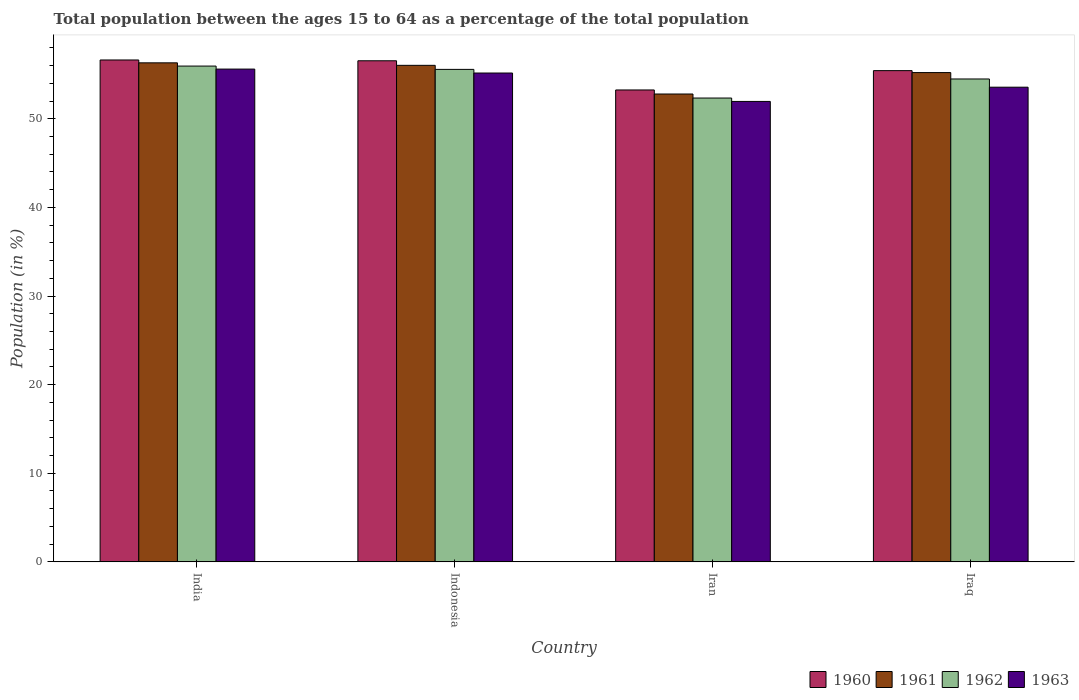How many different coloured bars are there?
Provide a succinct answer. 4. How many groups of bars are there?
Provide a succinct answer. 4. Are the number of bars per tick equal to the number of legend labels?
Provide a short and direct response. Yes. Are the number of bars on each tick of the X-axis equal?
Offer a very short reply. Yes. What is the label of the 2nd group of bars from the left?
Your response must be concise. Indonesia. What is the percentage of the population ages 15 to 64 in 1963 in Indonesia?
Provide a short and direct response. 55.17. Across all countries, what is the maximum percentage of the population ages 15 to 64 in 1961?
Provide a succinct answer. 56.32. Across all countries, what is the minimum percentage of the population ages 15 to 64 in 1960?
Offer a terse response. 53.25. In which country was the percentage of the population ages 15 to 64 in 1960 minimum?
Give a very brief answer. Iran. What is the total percentage of the population ages 15 to 64 in 1961 in the graph?
Keep it short and to the point. 220.36. What is the difference between the percentage of the population ages 15 to 64 in 1962 in India and that in Iran?
Offer a terse response. 3.61. What is the difference between the percentage of the population ages 15 to 64 in 1961 in Iran and the percentage of the population ages 15 to 64 in 1962 in India?
Give a very brief answer. -3.15. What is the average percentage of the population ages 15 to 64 in 1963 per country?
Provide a short and direct response. 54.08. What is the difference between the percentage of the population ages 15 to 64 of/in 1961 and percentage of the population ages 15 to 64 of/in 1960 in Iran?
Offer a terse response. -0.46. In how many countries, is the percentage of the population ages 15 to 64 in 1961 greater than 52?
Make the answer very short. 4. What is the ratio of the percentage of the population ages 15 to 64 in 1962 in India to that in Iraq?
Make the answer very short. 1.03. Is the percentage of the population ages 15 to 64 in 1961 in Indonesia less than that in Iraq?
Keep it short and to the point. No. Is the difference between the percentage of the population ages 15 to 64 in 1961 in Indonesia and Iraq greater than the difference between the percentage of the population ages 15 to 64 in 1960 in Indonesia and Iraq?
Provide a succinct answer. No. What is the difference between the highest and the second highest percentage of the population ages 15 to 64 in 1961?
Ensure brevity in your answer.  0.28. What is the difference between the highest and the lowest percentage of the population ages 15 to 64 in 1962?
Provide a succinct answer. 3.61. In how many countries, is the percentage of the population ages 15 to 64 in 1962 greater than the average percentage of the population ages 15 to 64 in 1962 taken over all countries?
Offer a terse response. 2. Is it the case that in every country, the sum of the percentage of the population ages 15 to 64 in 1963 and percentage of the population ages 15 to 64 in 1962 is greater than the sum of percentage of the population ages 15 to 64 in 1960 and percentage of the population ages 15 to 64 in 1961?
Give a very brief answer. No. What does the 1st bar from the left in Indonesia represents?
Give a very brief answer. 1960. Is it the case that in every country, the sum of the percentage of the population ages 15 to 64 in 1963 and percentage of the population ages 15 to 64 in 1961 is greater than the percentage of the population ages 15 to 64 in 1962?
Provide a short and direct response. Yes. How many bars are there?
Ensure brevity in your answer.  16. How many countries are there in the graph?
Your answer should be compact. 4. Does the graph contain any zero values?
Provide a short and direct response. No. What is the title of the graph?
Ensure brevity in your answer.  Total population between the ages 15 to 64 as a percentage of the total population. What is the label or title of the X-axis?
Your response must be concise. Country. What is the Population (in %) of 1960 in India?
Your answer should be very brief. 56.64. What is the Population (in %) of 1961 in India?
Offer a terse response. 56.32. What is the Population (in %) of 1962 in India?
Offer a terse response. 55.95. What is the Population (in %) of 1963 in India?
Your response must be concise. 55.61. What is the Population (in %) in 1960 in Indonesia?
Ensure brevity in your answer.  56.55. What is the Population (in %) in 1961 in Indonesia?
Make the answer very short. 56.03. What is the Population (in %) of 1962 in Indonesia?
Ensure brevity in your answer.  55.58. What is the Population (in %) of 1963 in Indonesia?
Provide a short and direct response. 55.17. What is the Population (in %) in 1960 in Iran?
Keep it short and to the point. 53.25. What is the Population (in %) of 1961 in Iran?
Make the answer very short. 52.8. What is the Population (in %) of 1962 in Iran?
Keep it short and to the point. 52.34. What is the Population (in %) of 1963 in Iran?
Keep it short and to the point. 51.96. What is the Population (in %) in 1960 in Iraq?
Keep it short and to the point. 55.43. What is the Population (in %) of 1961 in Iraq?
Offer a very short reply. 55.22. What is the Population (in %) of 1962 in Iraq?
Your answer should be compact. 54.49. What is the Population (in %) in 1963 in Iraq?
Keep it short and to the point. 53.57. Across all countries, what is the maximum Population (in %) in 1960?
Give a very brief answer. 56.64. Across all countries, what is the maximum Population (in %) of 1961?
Keep it short and to the point. 56.32. Across all countries, what is the maximum Population (in %) of 1962?
Ensure brevity in your answer.  55.95. Across all countries, what is the maximum Population (in %) of 1963?
Ensure brevity in your answer.  55.61. Across all countries, what is the minimum Population (in %) in 1960?
Provide a succinct answer. 53.25. Across all countries, what is the minimum Population (in %) of 1961?
Offer a very short reply. 52.8. Across all countries, what is the minimum Population (in %) of 1962?
Your response must be concise. 52.34. Across all countries, what is the minimum Population (in %) of 1963?
Give a very brief answer. 51.96. What is the total Population (in %) of 1960 in the graph?
Keep it short and to the point. 221.87. What is the total Population (in %) in 1961 in the graph?
Make the answer very short. 220.36. What is the total Population (in %) of 1962 in the graph?
Your response must be concise. 218.36. What is the total Population (in %) of 1963 in the graph?
Give a very brief answer. 216.3. What is the difference between the Population (in %) of 1960 in India and that in Indonesia?
Make the answer very short. 0.09. What is the difference between the Population (in %) in 1961 in India and that in Indonesia?
Provide a succinct answer. 0.28. What is the difference between the Population (in %) of 1962 in India and that in Indonesia?
Keep it short and to the point. 0.37. What is the difference between the Population (in %) in 1963 in India and that in Indonesia?
Provide a succinct answer. 0.44. What is the difference between the Population (in %) of 1960 in India and that in Iran?
Provide a short and direct response. 3.38. What is the difference between the Population (in %) in 1961 in India and that in Iran?
Provide a succinct answer. 3.52. What is the difference between the Population (in %) of 1962 in India and that in Iran?
Make the answer very short. 3.61. What is the difference between the Population (in %) of 1963 in India and that in Iran?
Make the answer very short. 3.65. What is the difference between the Population (in %) in 1960 in India and that in Iraq?
Provide a short and direct response. 1.2. What is the difference between the Population (in %) in 1961 in India and that in Iraq?
Give a very brief answer. 1.1. What is the difference between the Population (in %) in 1962 in India and that in Iraq?
Your response must be concise. 1.46. What is the difference between the Population (in %) of 1963 in India and that in Iraq?
Offer a very short reply. 2.04. What is the difference between the Population (in %) in 1960 in Indonesia and that in Iran?
Keep it short and to the point. 3.29. What is the difference between the Population (in %) in 1961 in Indonesia and that in Iran?
Provide a short and direct response. 3.24. What is the difference between the Population (in %) of 1962 in Indonesia and that in Iran?
Your response must be concise. 3.23. What is the difference between the Population (in %) of 1963 in Indonesia and that in Iran?
Your response must be concise. 3.21. What is the difference between the Population (in %) of 1960 in Indonesia and that in Iraq?
Keep it short and to the point. 1.11. What is the difference between the Population (in %) of 1961 in Indonesia and that in Iraq?
Your response must be concise. 0.82. What is the difference between the Population (in %) in 1962 in Indonesia and that in Iraq?
Provide a short and direct response. 1.08. What is the difference between the Population (in %) of 1963 in Indonesia and that in Iraq?
Provide a short and direct response. 1.6. What is the difference between the Population (in %) of 1960 in Iran and that in Iraq?
Provide a succinct answer. -2.18. What is the difference between the Population (in %) in 1961 in Iran and that in Iraq?
Make the answer very short. -2.42. What is the difference between the Population (in %) of 1962 in Iran and that in Iraq?
Your answer should be compact. -2.15. What is the difference between the Population (in %) of 1963 in Iran and that in Iraq?
Make the answer very short. -1.61. What is the difference between the Population (in %) in 1960 in India and the Population (in %) in 1961 in Indonesia?
Your response must be concise. 0.6. What is the difference between the Population (in %) of 1960 in India and the Population (in %) of 1962 in Indonesia?
Provide a short and direct response. 1.06. What is the difference between the Population (in %) in 1960 in India and the Population (in %) in 1963 in Indonesia?
Make the answer very short. 1.47. What is the difference between the Population (in %) of 1961 in India and the Population (in %) of 1962 in Indonesia?
Your answer should be compact. 0.74. What is the difference between the Population (in %) in 1961 in India and the Population (in %) in 1963 in Indonesia?
Your answer should be compact. 1.15. What is the difference between the Population (in %) in 1962 in India and the Population (in %) in 1963 in Indonesia?
Give a very brief answer. 0.78. What is the difference between the Population (in %) in 1960 in India and the Population (in %) in 1961 in Iran?
Provide a succinct answer. 3.84. What is the difference between the Population (in %) of 1960 in India and the Population (in %) of 1962 in Iran?
Your response must be concise. 4.3. What is the difference between the Population (in %) of 1960 in India and the Population (in %) of 1963 in Iran?
Your response must be concise. 4.68. What is the difference between the Population (in %) of 1961 in India and the Population (in %) of 1962 in Iran?
Your response must be concise. 3.97. What is the difference between the Population (in %) in 1961 in India and the Population (in %) in 1963 in Iran?
Your answer should be compact. 4.36. What is the difference between the Population (in %) of 1962 in India and the Population (in %) of 1963 in Iran?
Give a very brief answer. 3.99. What is the difference between the Population (in %) in 1960 in India and the Population (in %) in 1961 in Iraq?
Provide a short and direct response. 1.42. What is the difference between the Population (in %) in 1960 in India and the Population (in %) in 1962 in Iraq?
Offer a terse response. 2.14. What is the difference between the Population (in %) of 1960 in India and the Population (in %) of 1963 in Iraq?
Give a very brief answer. 3.07. What is the difference between the Population (in %) in 1961 in India and the Population (in %) in 1962 in Iraq?
Your answer should be compact. 1.82. What is the difference between the Population (in %) of 1961 in India and the Population (in %) of 1963 in Iraq?
Give a very brief answer. 2.75. What is the difference between the Population (in %) of 1962 in India and the Population (in %) of 1963 in Iraq?
Make the answer very short. 2.38. What is the difference between the Population (in %) in 1960 in Indonesia and the Population (in %) in 1961 in Iran?
Provide a short and direct response. 3.75. What is the difference between the Population (in %) of 1960 in Indonesia and the Population (in %) of 1962 in Iran?
Your answer should be very brief. 4.2. What is the difference between the Population (in %) of 1960 in Indonesia and the Population (in %) of 1963 in Iran?
Offer a terse response. 4.59. What is the difference between the Population (in %) in 1961 in Indonesia and the Population (in %) in 1962 in Iran?
Make the answer very short. 3.69. What is the difference between the Population (in %) of 1961 in Indonesia and the Population (in %) of 1963 in Iran?
Your response must be concise. 4.07. What is the difference between the Population (in %) in 1962 in Indonesia and the Population (in %) in 1963 in Iran?
Your response must be concise. 3.62. What is the difference between the Population (in %) in 1960 in Indonesia and the Population (in %) in 1961 in Iraq?
Offer a terse response. 1.33. What is the difference between the Population (in %) in 1960 in Indonesia and the Population (in %) in 1962 in Iraq?
Your response must be concise. 2.05. What is the difference between the Population (in %) of 1960 in Indonesia and the Population (in %) of 1963 in Iraq?
Offer a terse response. 2.98. What is the difference between the Population (in %) of 1961 in Indonesia and the Population (in %) of 1962 in Iraq?
Offer a very short reply. 1.54. What is the difference between the Population (in %) of 1961 in Indonesia and the Population (in %) of 1963 in Iraq?
Your answer should be very brief. 2.47. What is the difference between the Population (in %) in 1962 in Indonesia and the Population (in %) in 1963 in Iraq?
Offer a terse response. 2.01. What is the difference between the Population (in %) of 1960 in Iran and the Population (in %) of 1961 in Iraq?
Provide a succinct answer. -1.96. What is the difference between the Population (in %) in 1960 in Iran and the Population (in %) in 1962 in Iraq?
Offer a terse response. -1.24. What is the difference between the Population (in %) in 1960 in Iran and the Population (in %) in 1963 in Iraq?
Ensure brevity in your answer.  -0.31. What is the difference between the Population (in %) in 1961 in Iran and the Population (in %) in 1962 in Iraq?
Your answer should be compact. -1.7. What is the difference between the Population (in %) of 1961 in Iran and the Population (in %) of 1963 in Iraq?
Your answer should be very brief. -0.77. What is the difference between the Population (in %) of 1962 in Iran and the Population (in %) of 1963 in Iraq?
Ensure brevity in your answer.  -1.22. What is the average Population (in %) of 1960 per country?
Give a very brief answer. 55.47. What is the average Population (in %) in 1961 per country?
Offer a very short reply. 55.09. What is the average Population (in %) in 1962 per country?
Your response must be concise. 54.59. What is the average Population (in %) in 1963 per country?
Give a very brief answer. 54.08. What is the difference between the Population (in %) in 1960 and Population (in %) in 1961 in India?
Provide a succinct answer. 0.32. What is the difference between the Population (in %) of 1960 and Population (in %) of 1962 in India?
Make the answer very short. 0.69. What is the difference between the Population (in %) of 1960 and Population (in %) of 1963 in India?
Make the answer very short. 1.03. What is the difference between the Population (in %) of 1961 and Population (in %) of 1962 in India?
Provide a succinct answer. 0.37. What is the difference between the Population (in %) of 1961 and Population (in %) of 1963 in India?
Your answer should be very brief. 0.71. What is the difference between the Population (in %) in 1962 and Population (in %) in 1963 in India?
Ensure brevity in your answer.  0.34. What is the difference between the Population (in %) of 1960 and Population (in %) of 1961 in Indonesia?
Your answer should be compact. 0.51. What is the difference between the Population (in %) in 1960 and Population (in %) in 1963 in Indonesia?
Make the answer very short. 1.38. What is the difference between the Population (in %) of 1961 and Population (in %) of 1962 in Indonesia?
Your answer should be compact. 0.46. What is the difference between the Population (in %) of 1961 and Population (in %) of 1963 in Indonesia?
Keep it short and to the point. 0.87. What is the difference between the Population (in %) in 1962 and Population (in %) in 1963 in Indonesia?
Provide a short and direct response. 0.41. What is the difference between the Population (in %) in 1960 and Population (in %) in 1961 in Iran?
Your answer should be very brief. 0.46. What is the difference between the Population (in %) in 1960 and Population (in %) in 1962 in Iran?
Make the answer very short. 0.91. What is the difference between the Population (in %) in 1960 and Population (in %) in 1963 in Iran?
Ensure brevity in your answer.  1.29. What is the difference between the Population (in %) of 1961 and Population (in %) of 1962 in Iran?
Offer a terse response. 0.46. What is the difference between the Population (in %) of 1961 and Population (in %) of 1963 in Iran?
Your answer should be compact. 0.84. What is the difference between the Population (in %) in 1962 and Population (in %) in 1963 in Iran?
Your answer should be very brief. 0.38. What is the difference between the Population (in %) of 1960 and Population (in %) of 1961 in Iraq?
Make the answer very short. 0.22. What is the difference between the Population (in %) of 1960 and Population (in %) of 1962 in Iraq?
Your response must be concise. 0.94. What is the difference between the Population (in %) in 1960 and Population (in %) in 1963 in Iraq?
Your answer should be very brief. 1.87. What is the difference between the Population (in %) in 1961 and Population (in %) in 1962 in Iraq?
Make the answer very short. 0.72. What is the difference between the Population (in %) in 1961 and Population (in %) in 1963 in Iraq?
Offer a terse response. 1.65. What is the difference between the Population (in %) in 1962 and Population (in %) in 1963 in Iraq?
Offer a terse response. 0.93. What is the ratio of the Population (in %) of 1960 in India to that in Indonesia?
Provide a short and direct response. 1. What is the ratio of the Population (in %) in 1961 in India to that in Indonesia?
Ensure brevity in your answer.  1. What is the ratio of the Population (in %) in 1963 in India to that in Indonesia?
Provide a short and direct response. 1.01. What is the ratio of the Population (in %) in 1960 in India to that in Iran?
Ensure brevity in your answer.  1.06. What is the ratio of the Population (in %) in 1961 in India to that in Iran?
Your answer should be compact. 1.07. What is the ratio of the Population (in %) in 1962 in India to that in Iran?
Keep it short and to the point. 1.07. What is the ratio of the Population (in %) in 1963 in India to that in Iran?
Provide a succinct answer. 1.07. What is the ratio of the Population (in %) in 1960 in India to that in Iraq?
Give a very brief answer. 1.02. What is the ratio of the Population (in %) of 1961 in India to that in Iraq?
Your response must be concise. 1.02. What is the ratio of the Population (in %) in 1962 in India to that in Iraq?
Ensure brevity in your answer.  1.03. What is the ratio of the Population (in %) of 1963 in India to that in Iraq?
Make the answer very short. 1.04. What is the ratio of the Population (in %) of 1960 in Indonesia to that in Iran?
Your answer should be very brief. 1.06. What is the ratio of the Population (in %) in 1961 in Indonesia to that in Iran?
Make the answer very short. 1.06. What is the ratio of the Population (in %) of 1962 in Indonesia to that in Iran?
Offer a terse response. 1.06. What is the ratio of the Population (in %) of 1963 in Indonesia to that in Iran?
Your answer should be very brief. 1.06. What is the ratio of the Population (in %) of 1960 in Indonesia to that in Iraq?
Your answer should be compact. 1.02. What is the ratio of the Population (in %) in 1961 in Indonesia to that in Iraq?
Give a very brief answer. 1.01. What is the ratio of the Population (in %) of 1962 in Indonesia to that in Iraq?
Your answer should be very brief. 1.02. What is the ratio of the Population (in %) in 1963 in Indonesia to that in Iraq?
Give a very brief answer. 1.03. What is the ratio of the Population (in %) of 1960 in Iran to that in Iraq?
Ensure brevity in your answer.  0.96. What is the ratio of the Population (in %) in 1961 in Iran to that in Iraq?
Make the answer very short. 0.96. What is the ratio of the Population (in %) of 1962 in Iran to that in Iraq?
Ensure brevity in your answer.  0.96. What is the ratio of the Population (in %) of 1963 in Iran to that in Iraq?
Provide a succinct answer. 0.97. What is the difference between the highest and the second highest Population (in %) of 1960?
Offer a terse response. 0.09. What is the difference between the highest and the second highest Population (in %) in 1961?
Provide a short and direct response. 0.28. What is the difference between the highest and the second highest Population (in %) in 1962?
Your answer should be compact. 0.37. What is the difference between the highest and the second highest Population (in %) of 1963?
Provide a short and direct response. 0.44. What is the difference between the highest and the lowest Population (in %) of 1960?
Your answer should be compact. 3.38. What is the difference between the highest and the lowest Population (in %) in 1961?
Provide a short and direct response. 3.52. What is the difference between the highest and the lowest Population (in %) of 1962?
Your answer should be compact. 3.61. What is the difference between the highest and the lowest Population (in %) in 1963?
Give a very brief answer. 3.65. 